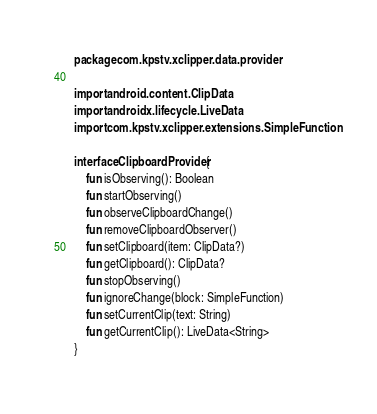Convert code to text. <code><loc_0><loc_0><loc_500><loc_500><_Kotlin_>package com.kpstv.xclipper.data.provider

import android.content.ClipData
import androidx.lifecycle.LiveData
import com.kpstv.xclipper.extensions.SimpleFunction

interface ClipboardProvider {
    fun isObserving(): Boolean
    fun startObserving()
    fun observeClipboardChange()
    fun removeClipboardObserver()
    fun setClipboard(item: ClipData?)
    fun getClipboard(): ClipData?
    fun stopObserving()
    fun ignoreChange(block: SimpleFunction)
    fun setCurrentClip(text: String)
    fun getCurrentClip(): LiveData<String>
}</code> 